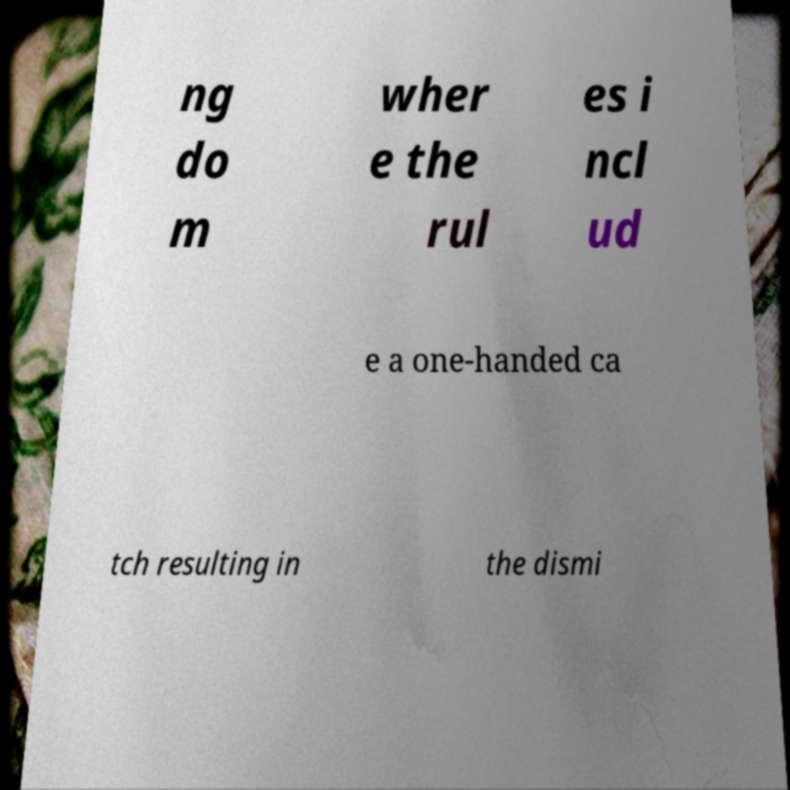I need the written content from this picture converted into text. Can you do that? ng do m wher e the rul es i ncl ud e a one-handed ca tch resulting in the dismi 